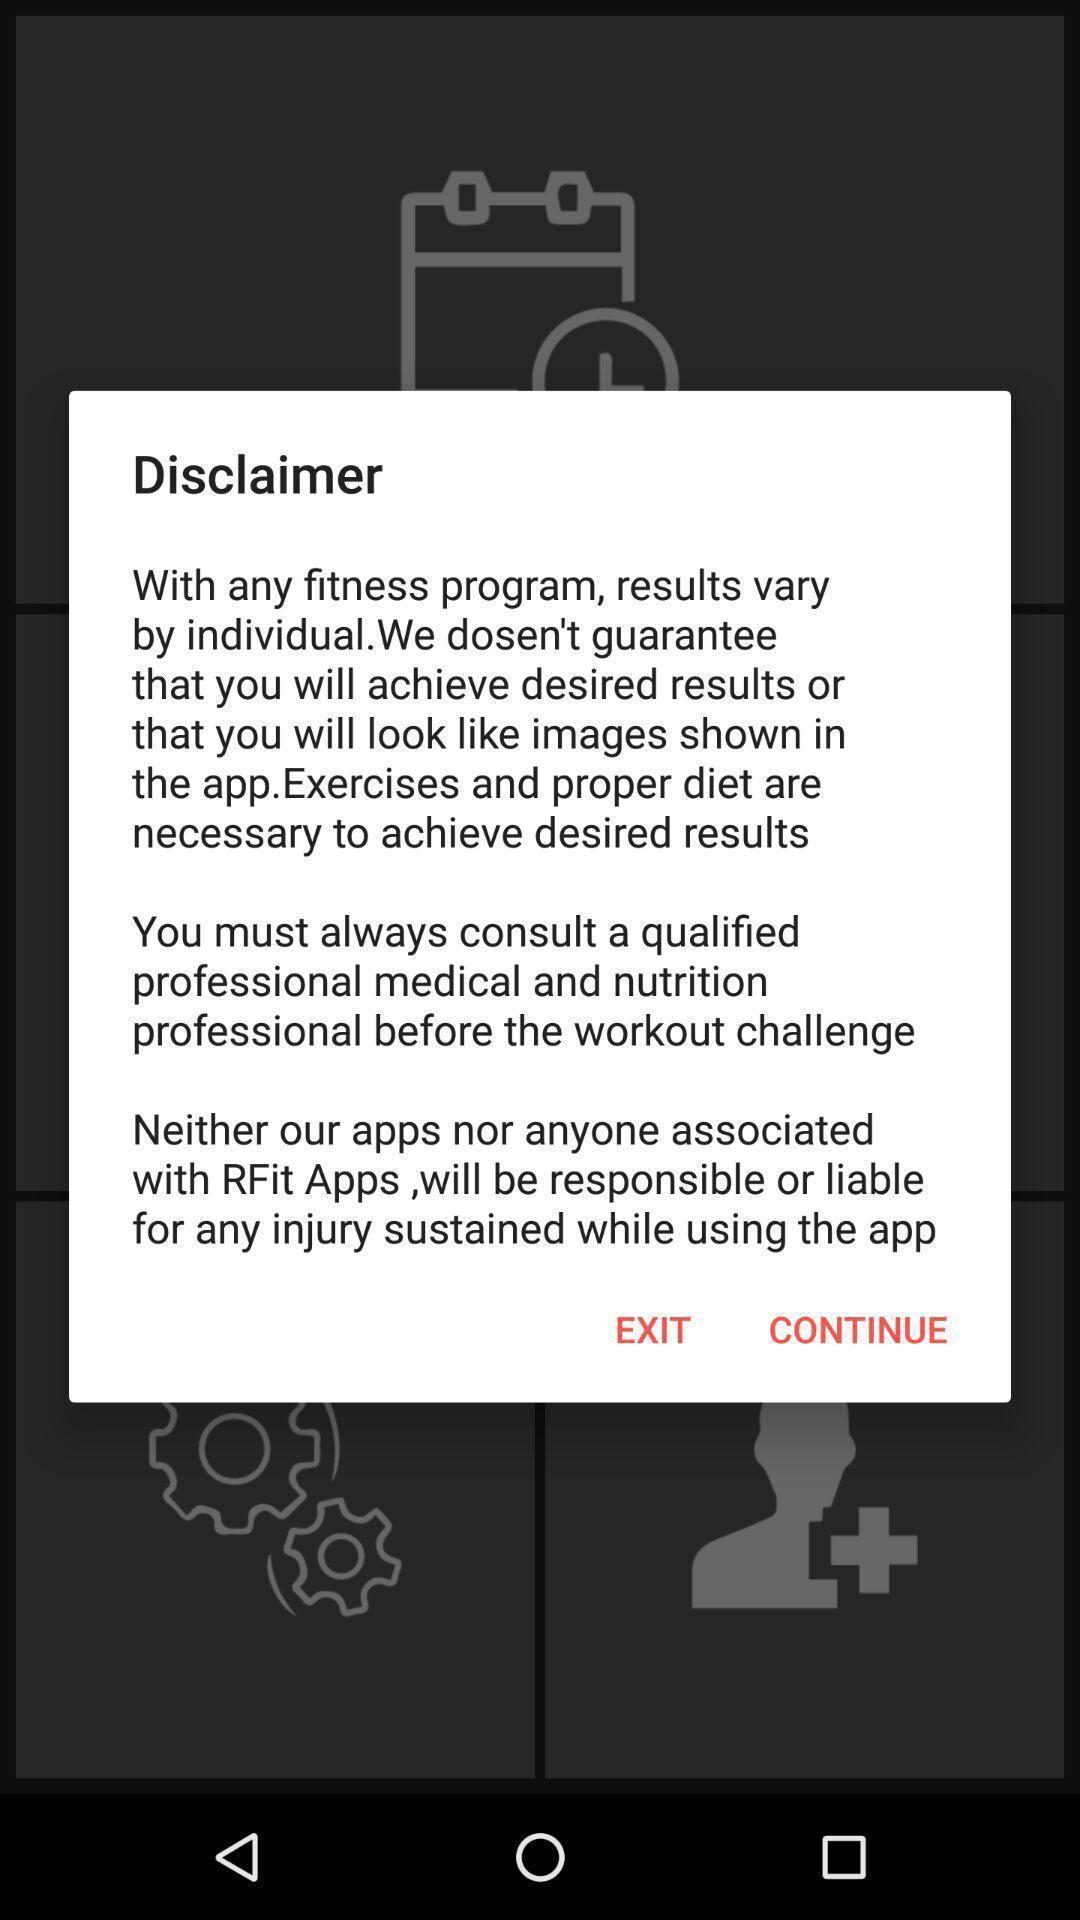Give me a narrative description of this picture. Pop-up showing disclaimer about the app. 